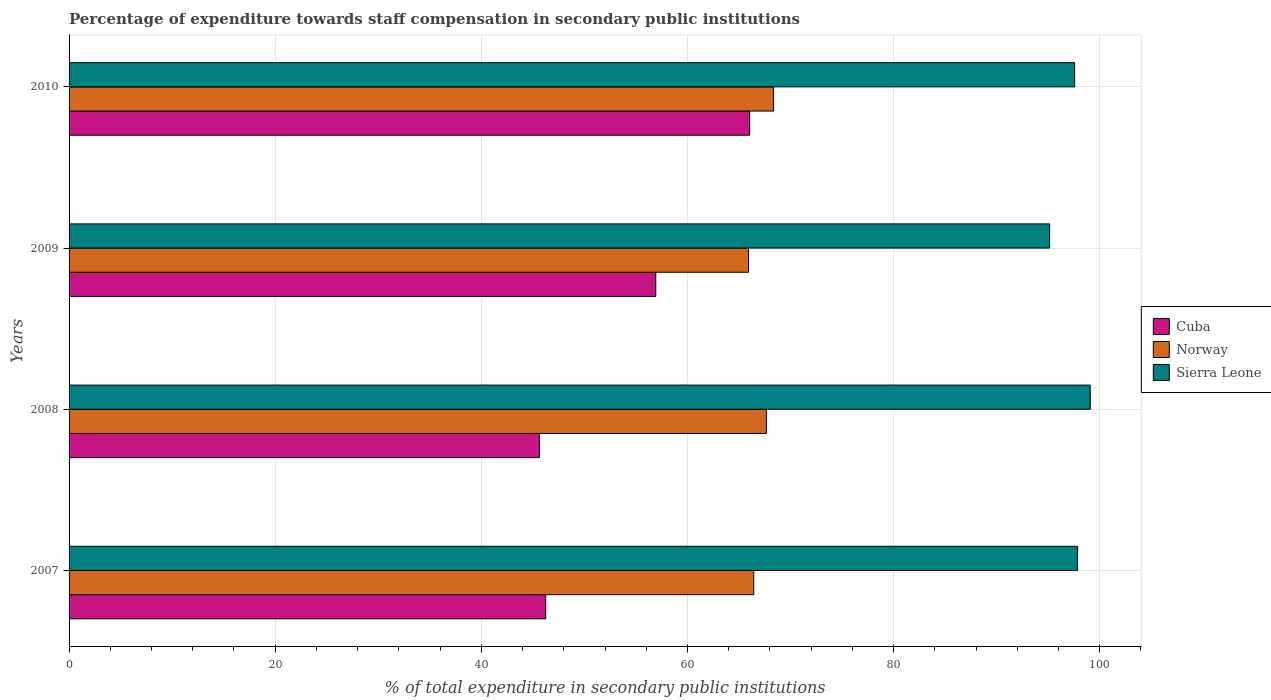How many groups of bars are there?
Your answer should be compact. 4. Are the number of bars on each tick of the Y-axis equal?
Provide a succinct answer. Yes. How many bars are there on the 1st tick from the top?
Provide a succinct answer. 3. In how many cases, is the number of bars for a given year not equal to the number of legend labels?
Offer a very short reply. 0. What is the percentage of expenditure towards staff compensation in Cuba in 2008?
Provide a succinct answer. 45.63. Across all years, what is the maximum percentage of expenditure towards staff compensation in Norway?
Provide a short and direct response. 68.36. Across all years, what is the minimum percentage of expenditure towards staff compensation in Cuba?
Make the answer very short. 45.63. What is the total percentage of expenditure towards staff compensation in Norway in the graph?
Make the answer very short. 268.37. What is the difference between the percentage of expenditure towards staff compensation in Sierra Leone in 2007 and that in 2010?
Offer a terse response. 0.29. What is the difference between the percentage of expenditure towards staff compensation in Cuba in 2008 and the percentage of expenditure towards staff compensation in Sierra Leone in 2007?
Your answer should be very brief. -52.22. What is the average percentage of expenditure towards staff compensation in Norway per year?
Give a very brief answer. 67.09. In the year 2007, what is the difference between the percentage of expenditure towards staff compensation in Sierra Leone and percentage of expenditure towards staff compensation in Norway?
Ensure brevity in your answer.  31.42. In how many years, is the percentage of expenditure towards staff compensation in Cuba greater than 64 %?
Your answer should be compact. 1. What is the ratio of the percentage of expenditure towards staff compensation in Norway in 2008 to that in 2009?
Offer a terse response. 1.03. What is the difference between the highest and the second highest percentage of expenditure towards staff compensation in Sierra Leone?
Ensure brevity in your answer.  1.23. What is the difference between the highest and the lowest percentage of expenditure towards staff compensation in Norway?
Offer a terse response. 2.43. In how many years, is the percentage of expenditure towards staff compensation in Cuba greater than the average percentage of expenditure towards staff compensation in Cuba taken over all years?
Make the answer very short. 2. What does the 1st bar from the top in 2010 represents?
Your answer should be compact. Sierra Leone. What does the 3rd bar from the bottom in 2009 represents?
Keep it short and to the point. Sierra Leone. Is it the case that in every year, the sum of the percentage of expenditure towards staff compensation in Norway and percentage of expenditure towards staff compensation in Cuba is greater than the percentage of expenditure towards staff compensation in Sierra Leone?
Provide a short and direct response. Yes. How many bars are there?
Keep it short and to the point. 12. What is the difference between two consecutive major ticks on the X-axis?
Provide a succinct answer. 20. Does the graph contain grids?
Your response must be concise. Yes. Where does the legend appear in the graph?
Provide a short and direct response. Center right. How many legend labels are there?
Keep it short and to the point. 3. What is the title of the graph?
Provide a succinct answer. Percentage of expenditure towards staff compensation in secondary public institutions. Does "Haiti" appear as one of the legend labels in the graph?
Your answer should be compact. No. What is the label or title of the X-axis?
Give a very brief answer. % of total expenditure in secondary public institutions. What is the label or title of the Y-axis?
Your response must be concise. Years. What is the % of total expenditure in secondary public institutions of Cuba in 2007?
Your response must be concise. 46.25. What is the % of total expenditure in secondary public institutions of Norway in 2007?
Provide a succinct answer. 66.43. What is the % of total expenditure in secondary public institutions in Sierra Leone in 2007?
Provide a succinct answer. 97.85. What is the % of total expenditure in secondary public institutions in Cuba in 2008?
Offer a very short reply. 45.63. What is the % of total expenditure in secondary public institutions in Norway in 2008?
Ensure brevity in your answer.  67.66. What is the % of total expenditure in secondary public institutions of Sierra Leone in 2008?
Offer a terse response. 99.08. What is the % of total expenditure in secondary public institutions in Cuba in 2009?
Make the answer very short. 56.92. What is the % of total expenditure in secondary public institutions in Norway in 2009?
Your answer should be compact. 65.93. What is the % of total expenditure in secondary public institutions in Sierra Leone in 2009?
Provide a succinct answer. 95.14. What is the % of total expenditure in secondary public institutions in Cuba in 2010?
Offer a terse response. 66.04. What is the % of total expenditure in secondary public institutions in Norway in 2010?
Provide a short and direct response. 68.36. What is the % of total expenditure in secondary public institutions in Sierra Leone in 2010?
Provide a succinct answer. 97.57. Across all years, what is the maximum % of total expenditure in secondary public institutions of Cuba?
Ensure brevity in your answer.  66.04. Across all years, what is the maximum % of total expenditure in secondary public institutions of Norway?
Offer a terse response. 68.36. Across all years, what is the maximum % of total expenditure in secondary public institutions of Sierra Leone?
Offer a terse response. 99.08. Across all years, what is the minimum % of total expenditure in secondary public institutions in Cuba?
Your response must be concise. 45.63. Across all years, what is the minimum % of total expenditure in secondary public institutions of Norway?
Make the answer very short. 65.93. Across all years, what is the minimum % of total expenditure in secondary public institutions in Sierra Leone?
Offer a very short reply. 95.14. What is the total % of total expenditure in secondary public institutions of Cuba in the graph?
Offer a very short reply. 214.84. What is the total % of total expenditure in secondary public institutions in Norway in the graph?
Your response must be concise. 268.37. What is the total % of total expenditure in secondary public institutions of Sierra Leone in the graph?
Make the answer very short. 389.65. What is the difference between the % of total expenditure in secondary public institutions in Cuba in 2007 and that in 2008?
Provide a succinct answer. 0.62. What is the difference between the % of total expenditure in secondary public institutions in Norway in 2007 and that in 2008?
Keep it short and to the point. -1.23. What is the difference between the % of total expenditure in secondary public institutions of Sierra Leone in 2007 and that in 2008?
Offer a terse response. -1.23. What is the difference between the % of total expenditure in secondary public institutions in Cuba in 2007 and that in 2009?
Make the answer very short. -10.68. What is the difference between the % of total expenditure in secondary public institutions in Norway in 2007 and that in 2009?
Ensure brevity in your answer.  0.5. What is the difference between the % of total expenditure in secondary public institutions in Sierra Leone in 2007 and that in 2009?
Your answer should be compact. 2.71. What is the difference between the % of total expenditure in secondary public institutions of Cuba in 2007 and that in 2010?
Give a very brief answer. -19.79. What is the difference between the % of total expenditure in secondary public institutions of Norway in 2007 and that in 2010?
Ensure brevity in your answer.  -1.93. What is the difference between the % of total expenditure in secondary public institutions of Sierra Leone in 2007 and that in 2010?
Offer a terse response. 0.29. What is the difference between the % of total expenditure in secondary public institutions of Cuba in 2008 and that in 2009?
Provide a short and direct response. -11.29. What is the difference between the % of total expenditure in secondary public institutions of Norway in 2008 and that in 2009?
Keep it short and to the point. 1.73. What is the difference between the % of total expenditure in secondary public institutions in Sierra Leone in 2008 and that in 2009?
Offer a terse response. 3.94. What is the difference between the % of total expenditure in secondary public institutions of Cuba in 2008 and that in 2010?
Offer a terse response. -20.41. What is the difference between the % of total expenditure in secondary public institutions of Norway in 2008 and that in 2010?
Give a very brief answer. -0.7. What is the difference between the % of total expenditure in secondary public institutions in Sierra Leone in 2008 and that in 2010?
Make the answer very short. 1.51. What is the difference between the % of total expenditure in secondary public institutions of Cuba in 2009 and that in 2010?
Your answer should be very brief. -9.11. What is the difference between the % of total expenditure in secondary public institutions in Norway in 2009 and that in 2010?
Keep it short and to the point. -2.43. What is the difference between the % of total expenditure in secondary public institutions in Sierra Leone in 2009 and that in 2010?
Your answer should be compact. -2.42. What is the difference between the % of total expenditure in secondary public institutions of Cuba in 2007 and the % of total expenditure in secondary public institutions of Norway in 2008?
Ensure brevity in your answer.  -21.41. What is the difference between the % of total expenditure in secondary public institutions in Cuba in 2007 and the % of total expenditure in secondary public institutions in Sierra Leone in 2008?
Make the answer very short. -52.83. What is the difference between the % of total expenditure in secondary public institutions of Norway in 2007 and the % of total expenditure in secondary public institutions of Sierra Leone in 2008?
Ensure brevity in your answer.  -32.65. What is the difference between the % of total expenditure in secondary public institutions of Cuba in 2007 and the % of total expenditure in secondary public institutions of Norway in 2009?
Keep it short and to the point. -19.68. What is the difference between the % of total expenditure in secondary public institutions of Cuba in 2007 and the % of total expenditure in secondary public institutions of Sierra Leone in 2009?
Your answer should be very brief. -48.89. What is the difference between the % of total expenditure in secondary public institutions of Norway in 2007 and the % of total expenditure in secondary public institutions of Sierra Leone in 2009?
Your response must be concise. -28.71. What is the difference between the % of total expenditure in secondary public institutions of Cuba in 2007 and the % of total expenditure in secondary public institutions of Norway in 2010?
Offer a very short reply. -22.11. What is the difference between the % of total expenditure in secondary public institutions in Cuba in 2007 and the % of total expenditure in secondary public institutions in Sierra Leone in 2010?
Keep it short and to the point. -51.32. What is the difference between the % of total expenditure in secondary public institutions in Norway in 2007 and the % of total expenditure in secondary public institutions in Sierra Leone in 2010?
Provide a short and direct response. -31.14. What is the difference between the % of total expenditure in secondary public institutions of Cuba in 2008 and the % of total expenditure in secondary public institutions of Norway in 2009?
Your answer should be very brief. -20.3. What is the difference between the % of total expenditure in secondary public institutions in Cuba in 2008 and the % of total expenditure in secondary public institutions in Sierra Leone in 2009?
Ensure brevity in your answer.  -49.51. What is the difference between the % of total expenditure in secondary public institutions in Norway in 2008 and the % of total expenditure in secondary public institutions in Sierra Leone in 2009?
Make the answer very short. -27.48. What is the difference between the % of total expenditure in secondary public institutions in Cuba in 2008 and the % of total expenditure in secondary public institutions in Norway in 2010?
Give a very brief answer. -22.73. What is the difference between the % of total expenditure in secondary public institutions of Cuba in 2008 and the % of total expenditure in secondary public institutions of Sierra Leone in 2010?
Offer a terse response. -51.94. What is the difference between the % of total expenditure in secondary public institutions in Norway in 2008 and the % of total expenditure in secondary public institutions in Sierra Leone in 2010?
Provide a succinct answer. -29.91. What is the difference between the % of total expenditure in secondary public institutions of Cuba in 2009 and the % of total expenditure in secondary public institutions of Norway in 2010?
Provide a succinct answer. -11.43. What is the difference between the % of total expenditure in secondary public institutions of Cuba in 2009 and the % of total expenditure in secondary public institutions of Sierra Leone in 2010?
Provide a short and direct response. -40.64. What is the difference between the % of total expenditure in secondary public institutions in Norway in 2009 and the % of total expenditure in secondary public institutions in Sierra Leone in 2010?
Make the answer very short. -31.64. What is the average % of total expenditure in secondary public institutions in Cuba per year?
Make the answer very short. 53.71. What is the average % of total expenditure in secondary public institutions in Norway per year?
Keep it short and to the point. 67.09. What is the average % of total expenditure in secondary public institutions in Sierra Leone per year?
Ensure brevity in your answer.  97.41. In the year 2007, what is the difference between the % of total expenditure in secondary public institutions of Cuba and % of total expenditure in secondary public institutions of Norway?
Offer a very short reply. -20.18. In the year 2007, what is the difference between the % of total expenditure in secondary public institutions of Cuba and % of total expenditure in secondary public institutions of Sierra Leone?
Provide a succinct answer. -51.61. In the year 2007, what is the difference between the % of total expenditure in secondary public institutions of Norway and % of total expenditure in secondary public institutions of Sierra Leone?
Provide a succinct answer. -31.42. In the year 2008, what is the difference between the % of total expenditure in secondary public institutions in Cuba and % of total expenditure in secondary public institutions in Norway?
Ensure brevity in your answer.  -22.03. In the year 2008, what is the difference between the % of total expenditure in secondary public institutions of Cuba and % of total expenditure in secondary public institutions of Sierra Leone?
Your answer should be very brief. -53.45. In the year 2008, what is the difference between the % of total expenditure in secondary public institutions in Norway and % of total expenditure in secondary public institutions in Sierra Leone?
Provide a short and direct response. -31.42. In the year 2009, what is the difference between the % of total expenditure in secondary public institutions in Cuba and % of total expenditure in secondary public institutions in Norway?
Ensure brevity in your answer.  -9. In the year 2009, what is the difference between the % of total expenditure in secondary public institutions in Cuba and % of total expenditure in secondary public institutions in Sierra Leone?
Provide a succinct answer. -38.22. In the year 2009, what is the difference between the % of total expenditure in secondary public institutions in Norway and % of total expenditure in secondary public institutions in Sierra Leone?
Offer a terse response. -29.21. In the year 2010, what is the difference between the % of total expenditure in secondary public institutions of Cuba and % of total expenditure in secondary public institutions of Norway?
Keep it short and to the point. -2.32. In the year 2010, what is the difference between the % of total expenditure in secondary public institutions of Cuba and % of total expenditure in secondary public institutions of Sierra Leone?
Offer a very short reply. -31.53. In the year 2010, what is the difference between the % of total expenditure in secondary public institutions of Norway and % of total expenditure in secondary public institutions of Sierra Leone?
Your answer should be compact. -29.21. What is the ratio of the % of total expenditure in secondary public institutions in Cuba in 2007 to that in 2008?
Provide a short and direct response. 1.01. What is the ratio of the % of total expenditure in secondary public institutions in Norway in 2007 to that in 2008?
Provide a succinct answer. 0.98. What is the ratio of the % of total expenditure in secondary public institutions of Sierra Leone in 2007 to that in 2008?
Make the answer very short. 0.99. What is the ratio of the % of total expenditure in secondary public institutions in Cuba in 2007 to that in 2009?
Your answer should be compact. 0.81. What is the ratio of the % of total expenditure in secondary public institutions in Norway in 2007 to that in 2009?
Keep it short and to the point. 1.01. What is the ratio of the % of total expenditure in secondary public institutions in Sierra Leone in 2007 to that in 2009?
Your response must be concise. 1.03. What is the ratio of the % of total expenditure in secondary public institutions of Cuba in 2007 to that in 2010?
Offer a very short reply. 0.7. What is the ratio of the % of total expenditure in secondary public institutions in Norway in 2007 to that in 2010?
Your answer should be very brief. 0.97. What is the ratio of the % of total expenditure in secondary public institutions of Cuba in 2008 to that in 2009?
Keep it short and to the point. 0.8. What is the ratio of the % of total expenditure in secondary public institutions in Norway in 2008 to that in 2009?
Give a very brief answer. 1.03. What is the ratio of the % of total expenditure in secondary public institutions in Sierra Leone in 2008 to that in 2009?
Your answer should be compact. 1.04. What is the ratio of the % of total expenditure in secondary public institutions of Cuba in 2008 to that in 2010?
Offer a very short reply. 0.69. What is the ratio of the % of total expenditure in secondary public institutions in Norway in 2008 to that in 2010?
Your answer should be very brief. 0.99. What is the ratio of the % of total expenditure in secondary public institutions in Sierra Leone in 2008 to that in 2010?
Your answer should be compact. 1.02. What is the ratio of the % of total expenditure in secondary public institutions in Cuba in 2009 to that in 2010?
Offer a terse response. 0.86. What is the ratio of the % of total expenditure in secondary public institutions in Norway in 2009 to that in 2010?
Offer a terse response. 0.96. What is the ratio of the % of total expenditure in secondary public institutions of Sierra Leone in 2009 to that in 2010?
Provide a short and direct response. 0.98. What is the difference between the highest and the second highest % of total expenditure in secondary public institutions in Cuba?
Your answer should be compact. 9.11. What is the difference between the highest and the second highest % of total expenditure in secondary public institutions of Norway?
Provide a short and direct response. 0.7. What is the difference between the highest and the second highest % of total expenditure in secondary public institutions in Sierra Leone?
Offer a very short reply. 1.23. What is the difference between the highest and the lowest % of total expenditure in secondary public institutions in Cuba?
Provide a short and direct response. 20.41. What is the difference between the highest and the lowest % of total expenditure in secondary public institutions of Norway?
Make the answer very short. 2.43. What is the difference between the highest and the lowest % of total expenditure in secondary public institutions of Sierra Leone?
Keep it short and to the point. 3.94. 